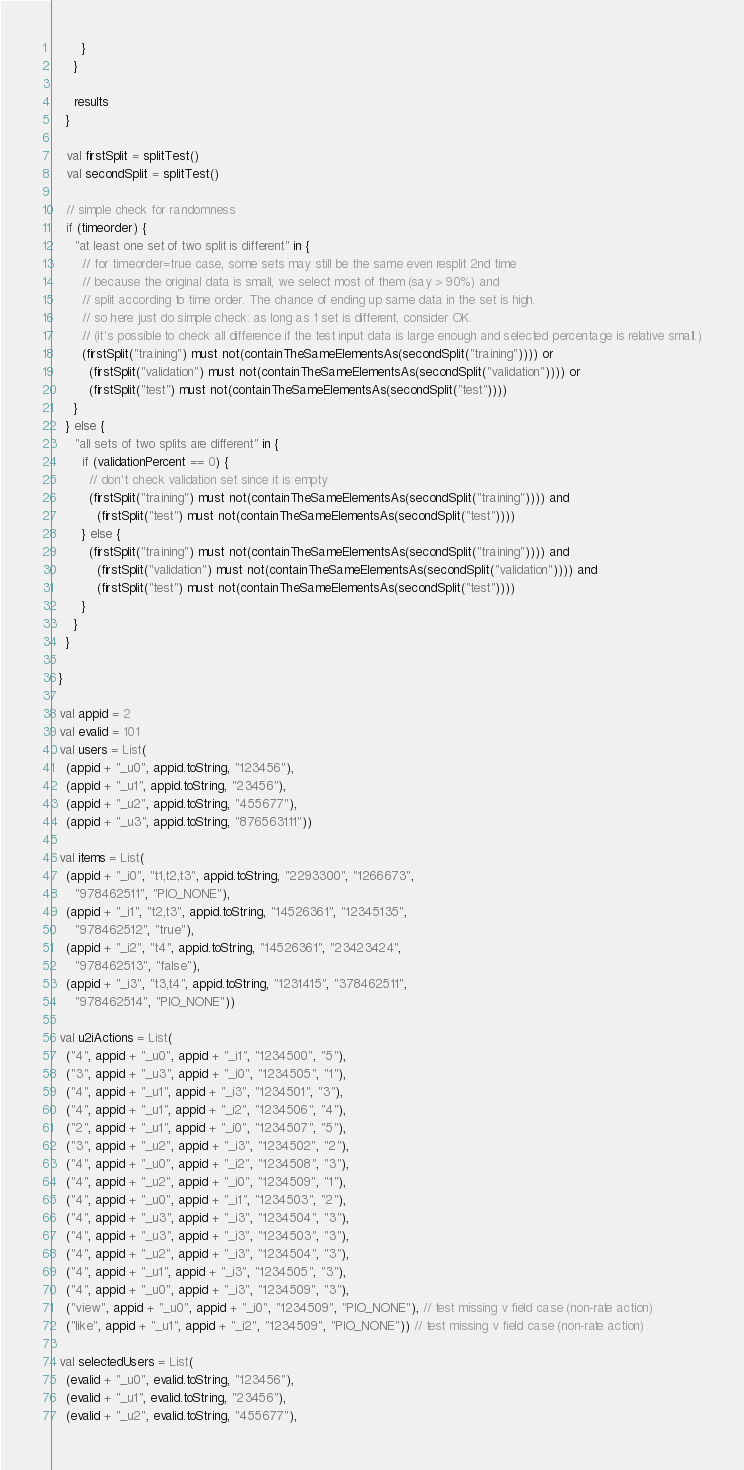Convert code to text. <code><loc_0><loc_0><loc_500><loc_500><_Scala_>        }
      }

      results
    }

    val firstSplit = splitTest()
    val secondSplit = splitTest()

    // simple check for randomness
    if (timeorder) {
      "at least one set of two split is different" in {
        // for timeorder=true case, some sets may still be the same even resplit 2nd time
        // because the original data is small, we select most of them (say > 90%) and
        // split according to time order. The chance of ending up same data in the set is high.
        // so here just do simple check: as long as 1 set is different, consider OK.
        // (it's possible to check all difference if the test input data is large enough and selected percentage is relative small.)
        (firstSplit("training") must not(containTheSameElementsAs(secondSplit("training")))) or
          (firstSplit("validation") must not(containTheSameElementsAs(secondSplit("validation")))) or
          (firstSplit("test") must not(containTheSameElementsAs(secondSplit("test"))))
      }
    } else {
      "all sets of two splits are different" in {
        if (validationPercent == 0) {
          // don't check validation set since it is empty
          (firstSplit("training") must not(containTheSameElementsAs(secondSplit("training")))) and
            (firstSplit("test") must not(containTheSameElementsAs(secondSplit("test"))))
        } else {
          (firstSplit("training") must not(containTheSameElementsAs(secondSplit("training")))) and
            (firstSplit("validation") must not(containTheSameElementsAs(secondSplit("validation")))) and
            (firstSplit("test") must not(containTheSameElementsAs(secondSplit("test"))))
        }
      }
    }

  }

  val appid = 2
  val evalid = 101
  val users = List(
    (appid + "_u0", appid.toString, "123456"),
    (appid + "_u1", appid.toString, "23456"),
    (appid + "_u2", appid.toString, "455677"),
    (appid + "_u3", appid.toString, "876563111"))

  val items = List(
    (appid + "_i0", "t1,t2,t3", appid.toString, "2293300", "1266673",
      "978462511", "PIO_NONE"),
    (appid + "_i1", "t2,t3", appid.toString, "14526361", "12345135",
      "978462512", "true"),
    (appid + "_i2", "t4", appid.toString, "14526361", "23423424",
      "978462513", "false"),
    (appid + "_i3", "t3,t4", appid.toString, "1231415", "378462511",
      "978462514", "PIO_NONE"))

  val u2iActions = List(
    ("4", appid + "_u0", appid + "_i1", "1234500", "5"),
    ("3", appid + "_u3", appid + "_i0", "1234505", "1"),
    ("4", appid + "_u1", appid + "_i3", "1234501", "3"),
    ("4", appid + "_u1", appid + "_i2", "1234506", "4"),
    ("2", appid + "_u1", appid + "_i0", "1234507", "5"),
    ("3", appid + "_u2", appid + "_i3", "1234502", "2"),
    ("4", appid + "_u0", appid + "_i2", "1234508", "3"),
    ("4", appid + "_u2", appid + "_i0", "1234509", "1"),
    ("4", appid + "_u0", appid + "_i1", "1234503", "2"),
    ("4", appid + "_u3", appid + "_i3", "1234504", "3"),
    ("4", appid + "_u3", appid + "_i3", "1234503", "3"),
    ("4", appid + "_u2", appid + "_i3", "1234504", "3"),
    ("4", appid + "_u1", appid + "_i3", "1234505", "3"),
    ("4", appid + "_u0", appid + "_i3", "1234509", "3"),
    ("view", appid + "_u0", appid + "_i0", "1234509", "PIO_NONE"), // test missing v field case (non-rate action)
    ("like", appid + "_u1", appid + "_i2", "1234509", "PIO_NONE")) // test missing v field case (non-rate action)

  val selectedUsers = List(
    (evalid + "_u0", evalid.toString, "123456"),
    (evalid + "_u1", evalid.toString, "23456"),
    (evalid + "_u2", evalid.toString, "455677"),</code> 